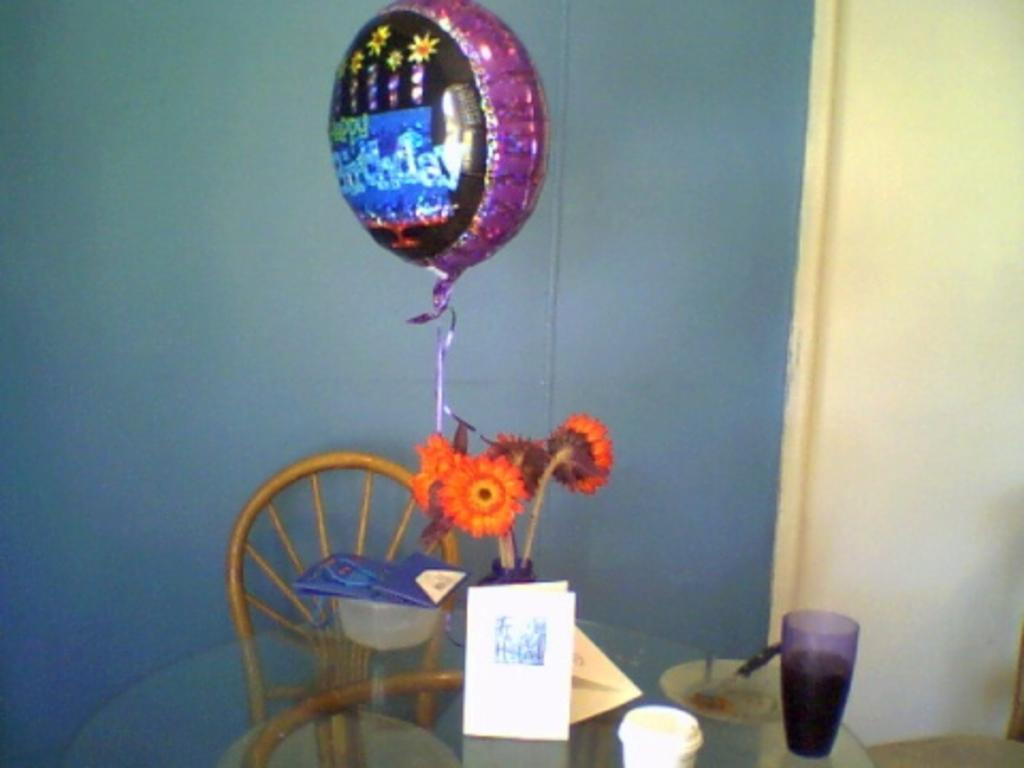What type of furniture is in the image? There is a dining table in the image. What is on the dining table? There is a flower vase on the table. Is there anything attached to the flower vase? Yes, there is a balloon tied to the flower vase. What is located behind the dining table? There is a chair behind the table. How many snakes are slithering on the dining table in the image? There are no snakes present on the dining table in the image. 